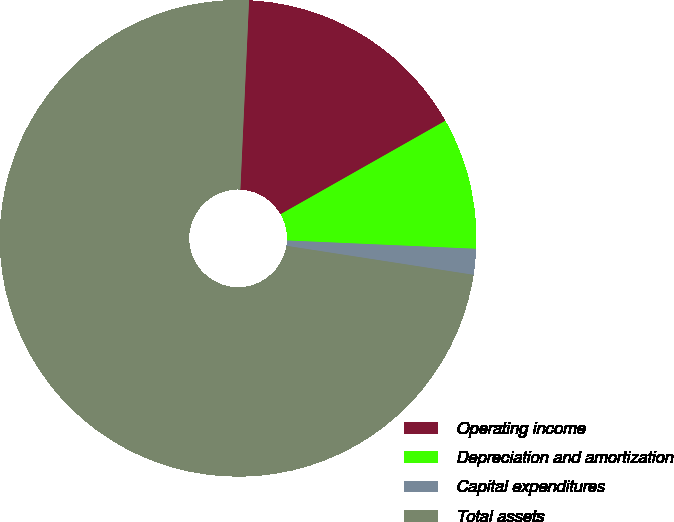Convert chart to OTSL. <chart><loc_0><loc_0><loc_500><loc_500><pie_chart><fcel>Operating income<fcel>Depreciation and amortization<fcel>Capital expenditures<fcel>Total assets<nl><fcel>16.06%<fcel>8.91%<fcel>1.75%<fcel>73.28%<nl></chart> 